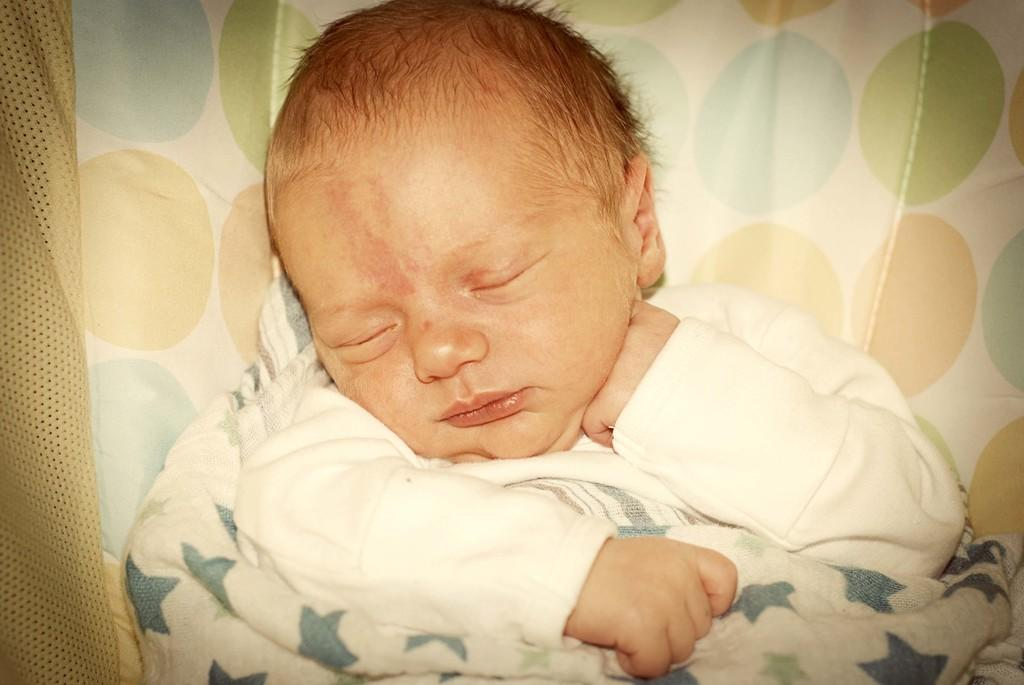What is the focus of the image? The image is zoomed in on an infant. What is the infant doing in the image? The infant is sleeping in the image. What is the infant covered with? The infant is covered with a blanket. What object is the infant resting on? The infant is on an object that appears to be a cradle. What side of the infant is facing the camera in the image? The image is zoomed in on the infant, so it is difficult to determine which side is facing the camera. What discovery was made while taking the image? There is no mention of a discovery in the provided facts, so we cannot answer this question. 